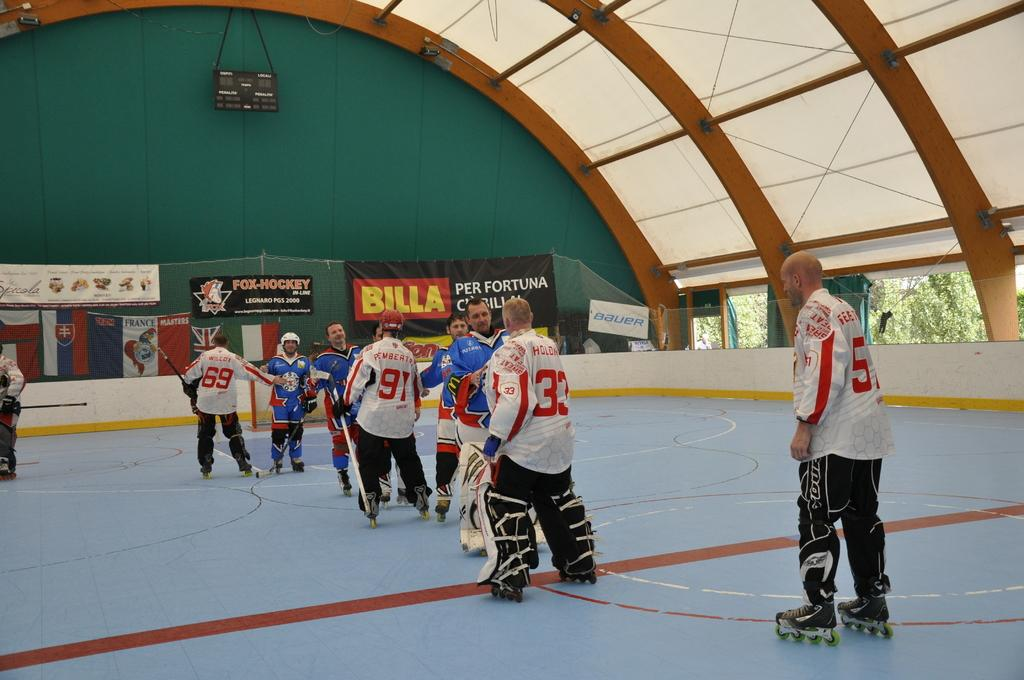Provide a one-sentence caption for the provided image. A sign says "BILLA" above a hockey rink. 